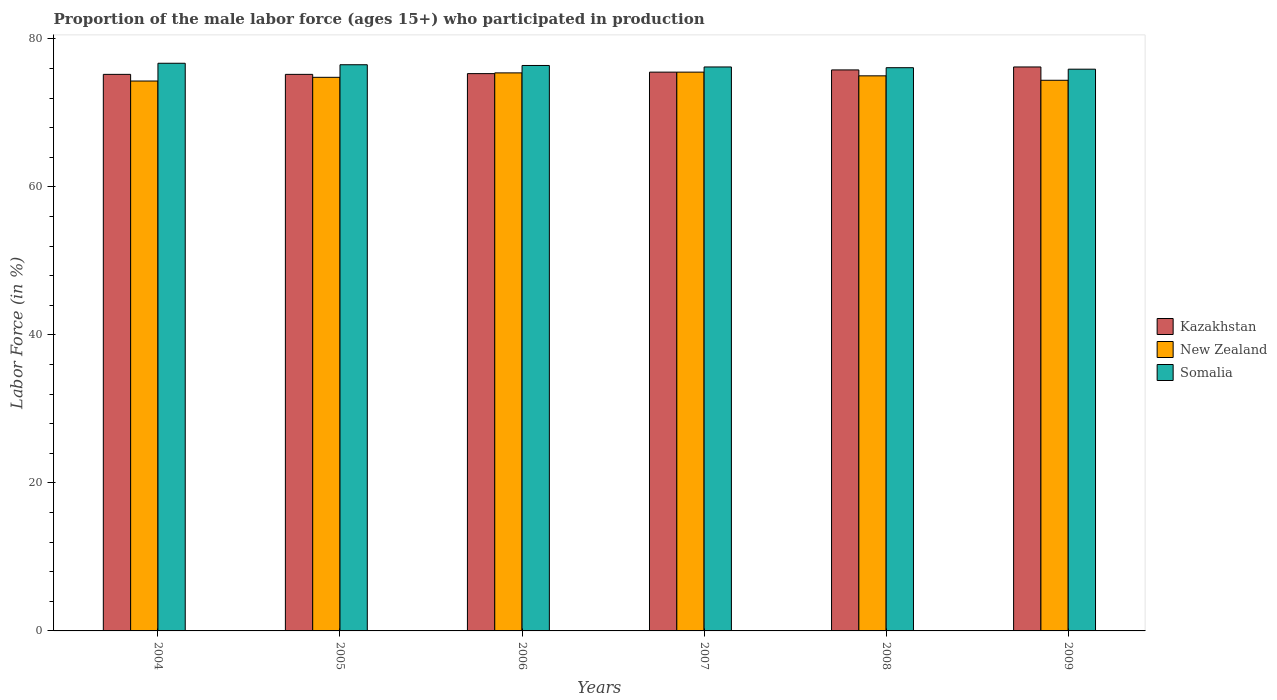How many different coloured bars are there?
Your answer should be very brief. 3. How many groups of bars are there?
Offer a very short reply. 6. Are the number of bars per tick equal to the number of legend labels?
Your response must be concise. Yes. Are the number of bars on each tick of the X-axis equal?
Offer a very short reply. Yes. How many bars are there on the 3rd tick from the left?
Your answer should be compact. 3. How many bars are there on the 4th tick from the right?
Your answer should be compact. 3. What is the label of the 1st group of bars from the left?
Offer a terse response. 2004. In how many cases, is the number of bars for a given year not equal to the number of legend labels?
Offer a very short reply. 0. What is the proportion of the male labor force who participated in production in Somalia in 2006?
Offer a very short reply. 76.4. Across all years, what is the maximum proportion of the male labor force who participated in production in Kazakhstan?
Keep it short and to the point. 76.2. Across all years, what is the minimum proportion of the male labor force who participated in production in Somalia?
Make the answer very short. 75.9. In which year was the proportion of the male labor force who participated in production in Kazakhstan maximum?
Give a very brief answer. 2009. In which year was the proportion of the male labor force who participated in production in Kazakhstan minimum?
Your answer should be compact. 2004. What is the total proportion of the male labor force who participated in production in Somalia in the graph?
Provide a short and direct response. 457.8. What is the difference between the proportion of the male labor force who participated in production in Somalia in 2007 and that in 2008?
Keep it short and to the point. 0.1. What is the difference between the proportion of the male labor force who participated in production in Kazakhstan in 2008 and the proportion of the male labor force who participated in production in Somalia in 2005?
Offer a terse response. -0.7. What is the average proportion of the male labor force who participated in production in New Zealand per year?
Make the answer very short. 74.9. In the year 2006, what is the difference between the proportion of the male labor force who participated in production in New Zealand and proportion of the male labor force who participated in production in Kazakhstan?
Make the answer very short. 0.1. What is the ratio of the proportion of the male labor force who participated in production in New Zealand in 2004 to that in 2007?
Ensure brevity in your answer.  0.98. Is the difference between the proportion of the male labor force who participated in production in New Zealand in 2005 and 2009 greater than the difference between the proportion of the male labor force who participated in production in Kazakhstan in 2005 and 2009?
Your response must be concise. Yes. What is the difference between the highest and the second highest proportion of the male labor force who participated in production in New Zealand?
Your answer should be compact. 0.1. What is the difference between the highest and the lowest proportion of the male labor force who participated in production in New Zealand?
Offer a terse response. 1.2. In how many years, is the proportion of the male labor force who participated in production in Kazakhstan greater than the average proportion of the male labor force who participated in production in Kazakhstan taken over all years?
Offer a terse response. 2. Is the sum of the proportion of the male labor force who participated in production in Kazakhstan in 2005 and 2006 greater than the maximum proportion of the male labor force who participated in production in New Zealand across all years?
Provide a succinct answer. Yes. What does the 3rd bar from the left in 2006 represents?
Give a very brief answer. Somalia. What does the 1st bar from the right in 2006 represents?
Keep it short and to the point. Somalia. How many bars are there?
Your response must be concise. 18. Are all the bars in the graph horizontal?
Offer a terse response. No. How many years are there in the graph?
Offer a terse response. 6. What is the difference between two consecutive major ticks on the Y-axis?
Provide a succinct answer. 20. Does the graph contain any zero values?
Provide a short and direct response. No. Does the graph contain grids?
Your answer should be very brief. No. Where does the legend appear in the graph?
Offer a terse response. Center right. How many legend labels are there?
Ensure brevity in your answer.  3. What is the title of the graph?
Your answer should be very brief. Proportion of the male labor force (ages 15+) who participated in production. Does "Kiribati" appear as one of the legend labels in the graph?
Offer a terse response. No. What is the Labor Force (in %) in Kazakhstan in 2004?
Your answer should be compact. 75.2. What is the Labor Force (in %) in New Zealand in 2004?
Your answer should be compact. 74.3. What is the Labor Force (in %) of Somalia in 2004?
Provide a succinct answer. 76.7. What is the Labor Force (in %) of Kazakhstan in 2005?
Provide a short and direct response. 75.2. What is the Labor Force (in %) in New Zealand in 2005?
Provide a succinct answer. 74.8. What is the Labor Force (in %) in Somalia in 2005?
Provide a succinct answer. 76.5. What is the Labor Force (in %) of Kazakhstan in 2006?
Make the answer very short. 75.3. What is the Labor Force (in %) of New Zealand in 2006?
Offer a very short reply. 75.4. What is the Labor Force (in %) of Somalia in 2006?
Provide a short and direct response. 76.4. What is the Labor Force (in %) in Kazakhstan in 2007?
Your response must be concise. 75.5. What is the Labor Force (in %) in New Zealand in 2007?
Give a very brief answer. 75.5. What is the Labor Force (in %) in Somalia in 2007?
Your response must be concise. 76.2. What is the Labor Force (in %) in Kazakhstan in 2008?
Offer a terse response. 75.8. What is the Labor Force (in %) of New Zealand in 2008?
Give a very brief answer. 75. What is the Labor Force (in %) of Somalia in 2008?
Provide a short and direct response. 76.1. What is the Labor Force (in %) of Kazakhstan in 2009?
Offer a very short reply. 76.2. What is the Labor Force (in %) of New Zealand in 2009?
Make the answer very short. 74.4. What is the Labor Force (in %) of Somalia in 2009?
Provide a short and direct response. 75.9. Across all years, what is the maximum Labor Force (in %) of Kazakhstan?
Offer a terse response. 76.2. Across all years, what is the maximum Labor Force (in %) in New Zealand?
Provide a succinct answer. 75.5. Across all years, what is the maximum Labor Force (in %) in Somalia?
Your answer should be compact. 76.7. Across all years, what is the minimum Labor Force (in %) of Kazakhstan?
Make the answer very short. 75.2. Across all years, what is the minimum Labor Force (in %) of New Zealand?
Offer a very short reply. 74.3. Across all years, what is the minimum Labor Force (in %) of Somalia?
Your answer should be compact. 75.9. What is the total Labor Force (in %) of Kazakhstan in the graph?
Ensure brevity in your answer.  453.2. What is the total Labor Force (in %) of New Zealand in the graph?
Keep it short and to the point. 449.4. What is the total Labor Force (in %) of Somalia in the graph?
Provide a short and direct response. 457.8. What is the difference between the Labor Force (in %) in Kazakhstan in 2004 and that in 2005?
Make the answer very short. 0. What is the difference between the Labor Force (in %) in New Zealand in 2004 and that in 2005?
Ensure brevity in your answer.  -0.5. What is the difference between the Labor Force (in %) in Kazakhstan in 2004 and that in 2007?
Keep it short and to the point. -0.3. What is the difference between the Labor Force (in %) of New Zealand in 2004 and that in 2007?
Your answer should be very brief. -1.2. What is the difference between the Labor Force (in %) in Kazakhstan in 2004 and that in 2008?
Your response must be concise. -0.6. What is the difference between the Labor Force (in %) of New Zealand in 2004 and that in 2008?
Your response must be concise. -0.7. What is the difference between the Labor Force (in %) in Somalia in 2004 and that in 2008?
Keep it short and to the point. 0.6. What is the difference between the Labor Force (in %) of Kazakhstan in 2004 and that in 2009?
Your response must be concise. -1. What is the difference between the Labor Force (in %) of New Zealand in 2004 and that in 2009?
Your answer should be compact. -0.1. What is the difference between the Labor Force (in %) in New Zealand in 2005 and that in 2006?
Ensure brevity in your answer.  -0.6. What is the difference between the Labor Force (in %) of Somalia in 2005 and that in 2006?
Your answer should be compact. 0.1. What is the difference between the Labor Force (in %) of New Zealand in 2005 and that in 2007?
Your answer should be very brief. -0.7. What is the difference between the Labor Force (in %) in Kazakhstan in 2005 and that in 2008?
Offer a terse response. -0.6. What is the difference between the Labor Force (in %) in Kazakhstan in 2005 and that in 2009?
Provide a short and direct response. -1. What is the difference between the Labor Force (in %) in New Zealand in 2005 and that in 2009?
Ensure brevity in your answer.  0.4. What is the difference between the Labor Force (in %) in Somalia in 2005 and that in 2009?
Provide a succinct answer. 0.6. What is the difference between the Labor Force (in %) in Kazakhstan in 2006 and that in 2007?
Offer a very short reply. -0.2. What is the difference between the Labor Force (in %) of New Zealand in 2006 and that in 2007?
Your response must be concise. -0.1. What is the difference between the Labor Force (in %) in Kazakhstan in 2006 and that in 2008?
Your answer should be compact. -0.5. What is the difference between the Labor Force (in %) of Somalia in 2006 and that in 2008?
Make the answer very short. 0.3. What is the difference between the Labor Force (in %) in Kazakhstan in 2006 and that in 2009?
Provide a short and direct response. -0.9. What is the difference between the Labor Force (in %) of New Zealand in 2006 and that in 2009?
Offer a terse response. 1. What is the difference between the Labor Force (in %) in Kazakhstan in 2007 and that in 2009?
Ensure brevity in your answer.  -0.7. What is the difference between the Labor Force (in %) of Somalia in 2007 and that in 2009?
Provide a succinct answer. 0.3. What is the difference between the Labor Force (in %) in Somalia in 2008 and that in 2009?
Your response must be concise. 0.2. What is the difference between the Labor Force (in %) of Kazakhstan in 2004 and the Labor Force (in %) of New Zealand in 2005?
Your response must be concise. 0.4. What is the difference between the Labor Force (in %) of New Zealand in 2004 and the Labor Force (in %) of Somalia in 2005?
Ensure brevity in your answer.  -2.2. What is the difference between the Labor Force (in %) of New Zealand in 2004 and the Labor Force (in %) of Somalia in 2006?
Provide a short and direct response. -2.1. What is the difference between the Labor Force (in %) of Kazakhstan in 2004 and the Labor Force (in %) of New Zealand in 2007?
Your answer should be very brief. -0.3. What is the difference between the Labor Force (in %) of New Zealand in 2004 and the Labor Force (in %) of Somalia in 2007?
Your answer should be very brief. -1.9. What is the difference between the Labor Force (in %) in Kazakhstan in 2004 and the Labor Force (in %) in New Zealand in 2009?
Provide a succinct answer. 0.8. What is the difference between the Labor Force (in %) of Kazakhstan in 2005 and the Labor Force (in %) of New Zealand in 2006?
Offer a terse response. -0.2. What is the difference between the Labor Force (in %) of New Zealand in 2005 and the Labor Force (in %) of Somalia in 2006?
Provide a short and direct response. -1.6. What is the difference between the Labor Force (in %) of Kazakhstan in 2005 and the Labor Force (in %) of New Zealand in 2007?
Your answer should be compact. -0.3. What is the difference between the Labor Force (in %) of Kazakhstan in 2005 and the Labor Force (in %) of Somalia in 2007?
Keep it short and to the point. -1. What is the difference between the Labor Force (in %) of New Zealand in 2005 and the Labor Force (in %) of Somalia in 2007?
Provide a succinct answer. -1.4. What is the difference between the Labor Force (in %) in Kazakhstan in 2005 and the Labor Force (in %) in New Zealand in 2008?
Your response must be concise. 0.2. What is the difference between the Labor Force (in %) in Kazakhstan in 2005 and the Labor Force (in %) in Somalia in 2009?
Offer a terse response. -0.7. What is the difference between the Labor Force (in %) in Kazakhstan in 2006 and the Labor Force (in %) in New Zealand in 2007?
Provide a short and direct response. -0.2. What is the difference between the Labor Force (in %) of Kazakhstan in 2006 and the Labor Force (in %) of Somalia in 2007?
Keep it short and to the point. -0.9. What is the difference between the Labor Force (in %) in New Zealand in 2006 and the Labor Force (in %) in Somalia in 2007?
Your answer should be very brief. -0.8. What is the difference between the Labor Force (in %) in Kazakhstan in 2006 and the Labor Force (in %) in New Zealand in 2009?
Provide a short and direct response. 0.9. What is the difference between the Labor Force (in %) in Kazakhstan in 2006 and the Labor Force (in %) in Somalia in 2009?
Offer a terse response. -0.6. What is the difference between the Labor Force (in %) of New Zealand in 2006 and the Labor Force (in %) of Somalia in 2009?
Ensure brevity in your answer.  -0.5. What is the difference between the Labor Force (in %) of Kazakhstan in 2007 and the Labor Force (in %) of New Zealand in 2008?
Make the answer very short. 0.5. What is the difference between the Labor Force (in %) in New Zealand in 2007 and the Labor Force (in %) in Somalia in 2008?
Your response must be concise. -0.6. What is the difference between the Labor Force (in %) in Kazakhstan in 2007 and the Labor Force (in %) in New Zealand in 2009?
Provide a short and direct response. 1.1. What is the difference between the Labor Force (in %) in Kazakhstan in 2008 and the Labor Force (in %) in New Zealand in 2009?
Keep it short and to the point. 1.4. What is the average Labor Force (in %) in Kazakhstan per year?
Your response must be concise. 75.53. What is the average Labor Force (in %) in New Zealand per year?
Give a very brief answer. 74.9. What is the average Labor Force (in %) of Somalia per year?
Keep it short and to the point. 76.3. In the year 2004, what is the difference between the Labor Force (in %) of Kazakhstan and Labor Force (in %) of New Zealand?
Your answer should be compact. 0.9. In the year 2004, what is the difference between the Labor Force (in %) of Kazakhstan and Labor Force (in %) of Somalia?
Your answer should be very brief. -1.5. In the year 2005, what is the difference between the Labor Force (in %) in Kazakhstan and Labor Force (in %) in New Zealand?
Offer a terse response. 0.4. In the year 2005, what is the difference between the Labor Force (in %) of Kazakhstan and Labor Force (in %) of Somalia?
Offer a very short reply. -1.3. In the year 2005, what is the difference between the Labor Force (in %) of New Zealand and Labor Force (in %) of Somalia?
Offer a very short reply. -1.7. In the year 2006, what is the difference between the Labor Force (in %) in Kazakhstan and Labor Force (in %) in Somalia?
Provide a succinct answer. -1.1. In the year 2006, what is the difference between the Labor Force (in %) of New Zealand and Labor Force (in %) of Somalia?
Make the answer very short. -1. In the year 2007, what is the difference between the Labor Force (in %) of Kazakhstan and Labor Force (in %) of Somalia?
Give a very brief answer. -0.7. In the year 2008, what is the difference between the Labor Force (in %) in Kazakhstan and Labor Force (in %) in New Zealand?
Make the answer very short. 0.8. In the year 2008, what is the difference between the Labor Force (in %) of Kazakhstan and Labor Force (in %) of Somalia?
Offer a terse response. -0.3. In the year 2009, what is the difference between the Labor Force (in %) of Kazakhstan and Labor Force (in %) of New Zealand?
Offer a terse response. 1.8. What is the ratio of the Labor Force (in %) in Kazakhstan in 2004 to that in 2005?
Your answer should be compact. 1. What is the ratio of the Labor Force (in %) in Somalia in 2004 to that in 2005?
Keep it short and to the point. 1. What is the ratio of the Labor Force (in %) in New Zealand in 2004 to that in 2006?
Provide a short and direct response. 0.99. What is the ratio of the Labor Force (in %) of Somalia in 2004 to that in 2006?
Provide a succinct answer. 1. What is the ratio of the Labor Force (in %) in New Zealand in 2004 to that in 2007?
Offer a terse response. 0.98. What is the ratio of the Labor Force (in %) in Somalia in 2004 to that in 2007?
Offer a terse response. 1.01. What is the ratio of the Labor Force (in %) of New Zealand in 2004 to that in 2008?
Your answer should be very brief. 0.99. What is the ratio of the Labor Force (in %) of Somalia in 2004 to that in 2008?
Provide a short and direct response. 1.01. What is the ratio of the Labor Force (in %) of Kazakhstan in 2004 to that in 2009?
Give a very brief answer. 0.99. What is the ratio of the Labor Force (in %) of Somalia in 2004 to that in 2009?
Your answer should be very brief. 1.01. What is the ratio of the Labor Force (in %) of New Zealand in 2005 to that in 2006?
Provide a succinct answer. 0.99. What is the ratio of the Labor Force (in %) in Somalia in 2005 to that in 2006?
Keep it short and to the point. 1. What is the ratio of the Labor Force (in %) in Kazakhstan in 2005 to that in 2007?
Your answer should be compact. 1. What is the ratio of the Labor Force (in %) of New Zealand in 2005 to that in 2007?
Offer a very short reply. 0.99. What is the ratio of the Labor Force (in %) in Somalia in 2005 to that in 2008?
Offer a very short reply. 1.01. What is the ratio of the Labor Force (in %) in Kazakhstan in 2005 to that in 2009?
Provide a short and direct response. 0.99. What is the ratio of the Labor Force (in %) in New Zealand in 2005 to that in 2009?
Offer a very short reply. 1.01. What is the ratio of the Labor Force (in %) in Somalia in 2005 to that in 2009?
Your answer should be very brief. 1.01. What is the ratio of the Labor Force (in %) in Kazakhstan in 2006 to that in 2007?
Your answer should be very brief. 1. What is the ratio of the Labor Force (in %) in New Zealand in 2006 to that in 2007?
Give a very brief answer. 1. What is the ratio of the Labor Force (in %) of Somalia in 2006 to that in 2007?
Keep it short and to the point. 1. What is the ratio of the Labor Force (in %) of Kazakhstan in 2006 to that in 2008?
Give a very brief answer. 0.99. What is the ratio of the Labor Force (in %) of New Zealand in 2006 to that in 2008?
Your response must be concise. 1.01. What is the ratio of the Labor Force (in %) in Somalia in 2006 to that in 2008?
Your answer should be compact. 1. What is the ratio of the Labor Force (in %) of New Zealand in 2006 to that in 2009?
Your response must be concise. 1.01. What is the ratio of the Labor Force (in %) of Somalia in 2006 to that in 2009?
Give a very brief answer. 1.01. What is the ratio of the Labor Force (in %) in Kazakhstan in 2007 to that in 2008?
Your answer should be compact. 1. What is the ratio of the Labor Force (in %) in New Zealand in 2007 to that in 2008?
Your response must be concise. 1.01. What is the ratio of the Labor Force (in %) in Kazakhstan in 2007 to that in 2009?
Keep it short and to the point. 0.99. What is the ratio of the Labor Force (in %) of New Zealand in 2007 to that in 2009?
Your response must be concise. 1.01. What is the ratio of the Labor Force (in %) of Kazakhstan in 2008 to that in 2009?
Provide a short and direct response. 0.99. What is the ratio of the Labor Force (in %) of New Zealand in 2008 to that in 2009?
Your response must be concise. 1.01. What is the difference between the highest and the second highest Labor Force (in %) of Kazakhstan?
Offer a very short reply. 0.4. What is the difference between the highest and the second highest Labor Force (in %) of New Zealand?
Ensure brevity in your answer.  0.1. What is the difference between the highest and the second highest Labor Force (in %) in Somalia?
Provide a succinct answer. 0.2. What is the difference between the highest and the lowest Labor Force (in %) of New Zealand?
Your response must be concise. 1.2. 